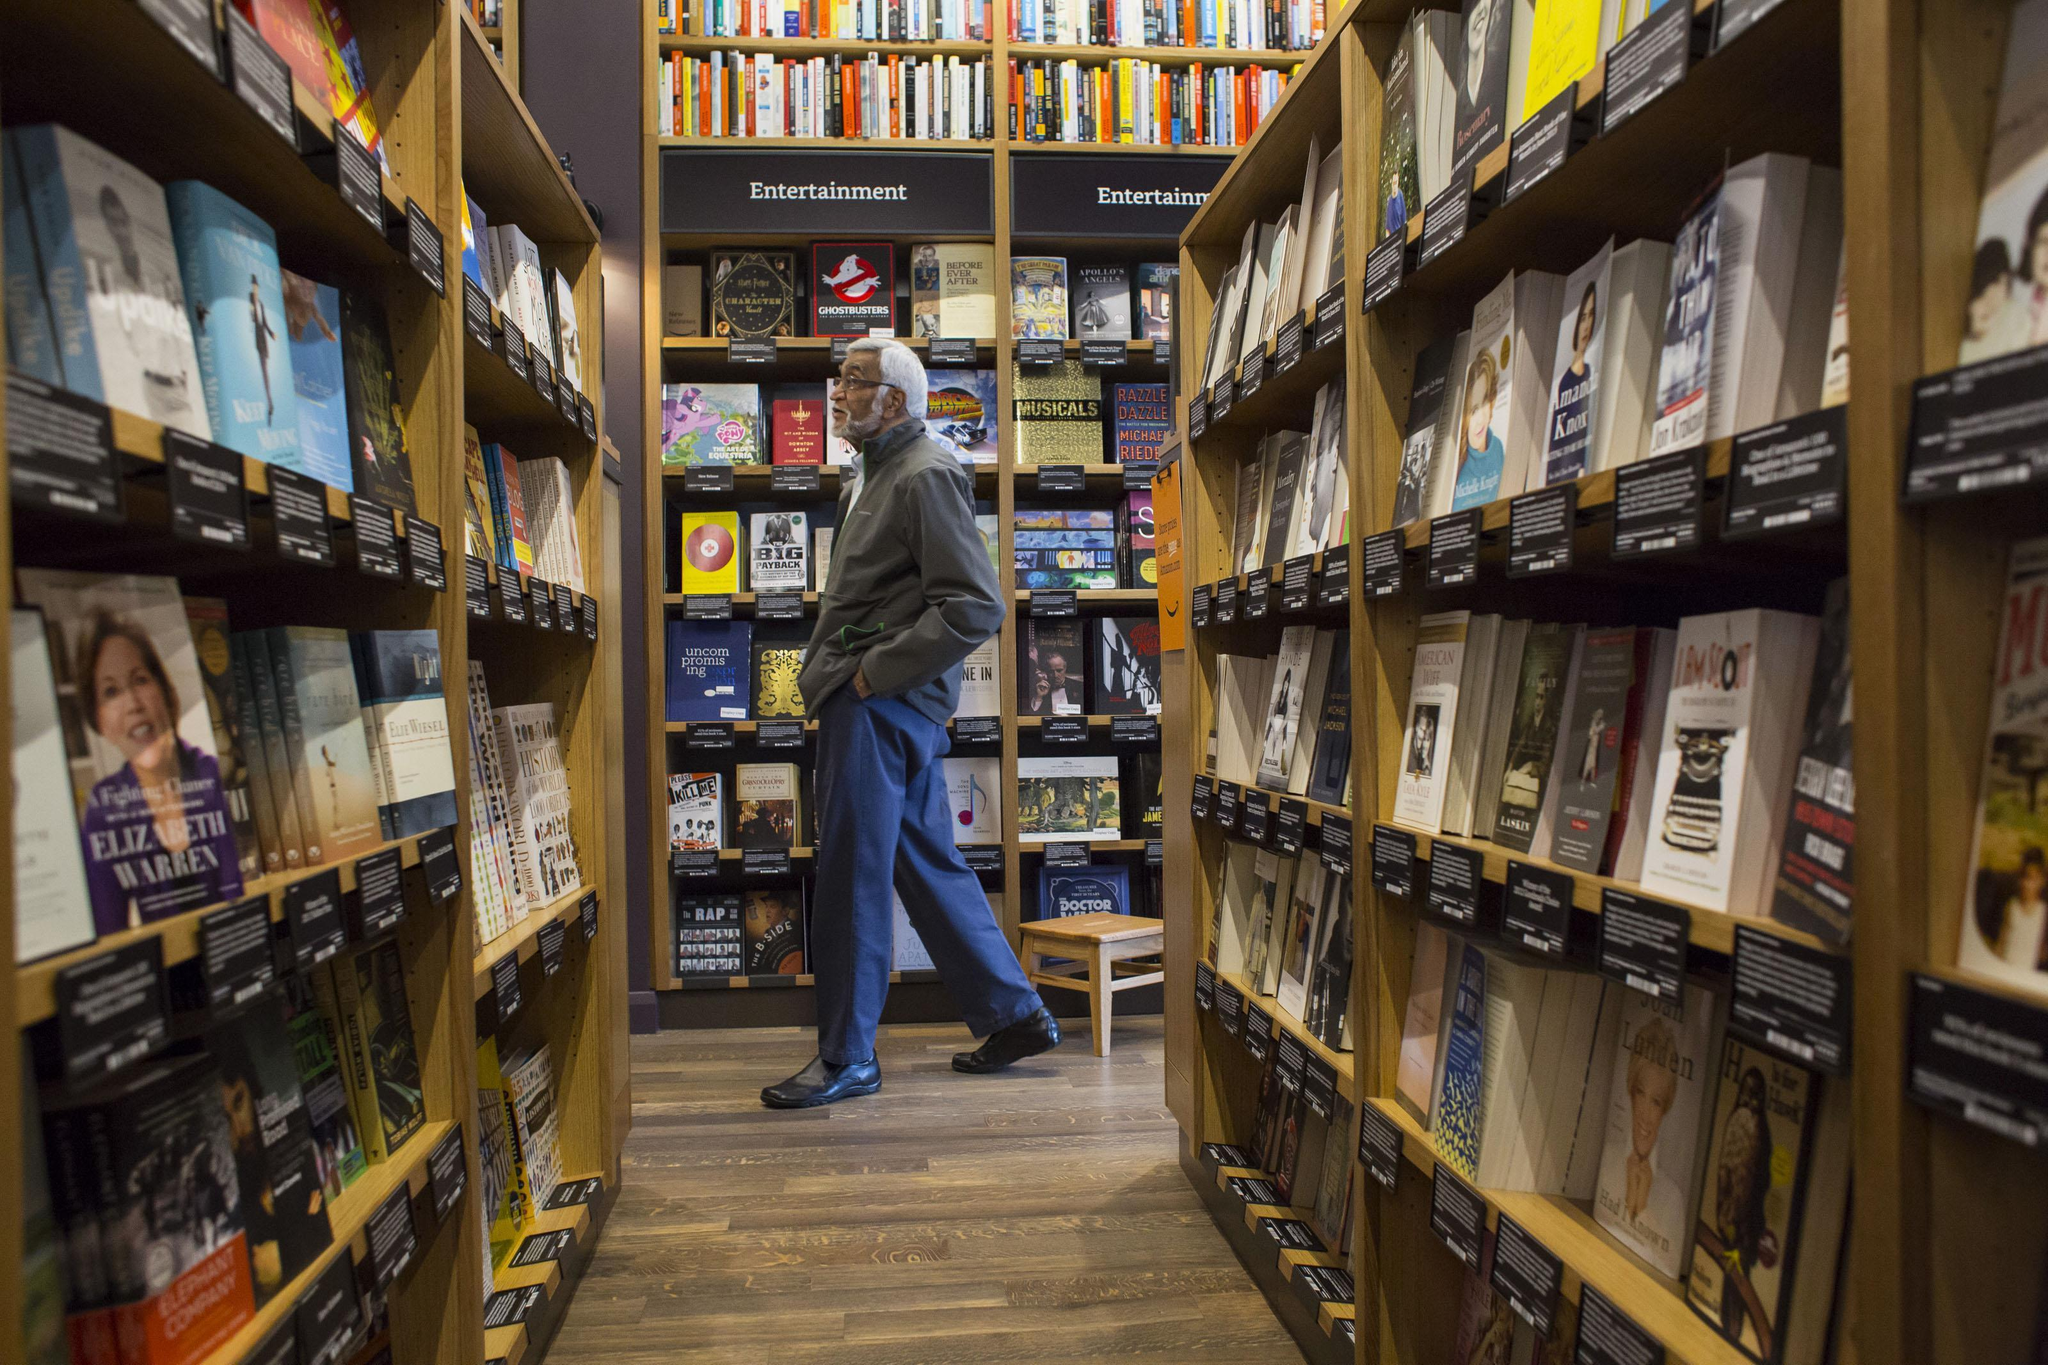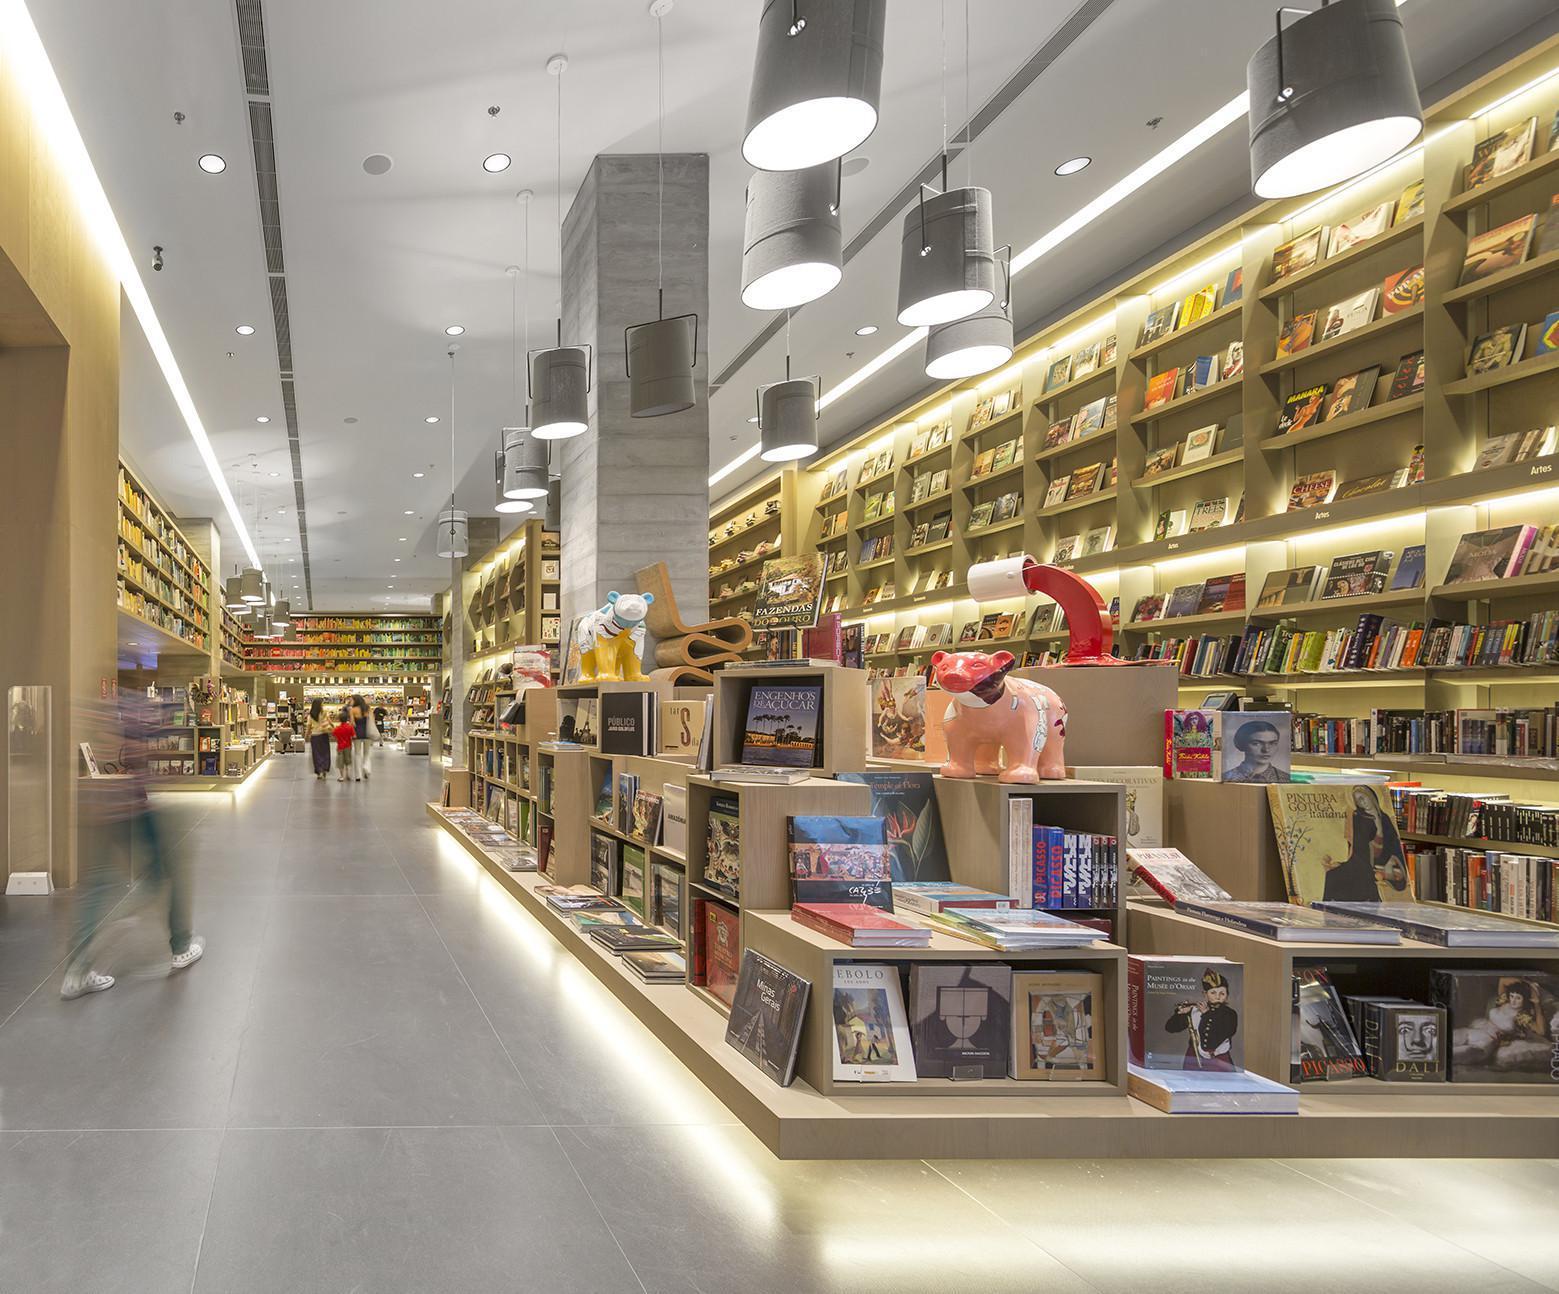The first image is the image on the left, the second image is the image on the right. Evaluate the accuracy of this statement regarding the images: "The left and right images show someone standing at the end of an aisle of books, but not in front of a table display.". Is it true? Answer yes or no. Yes. 